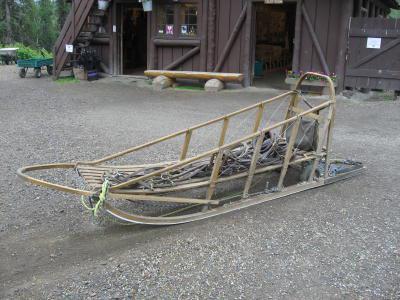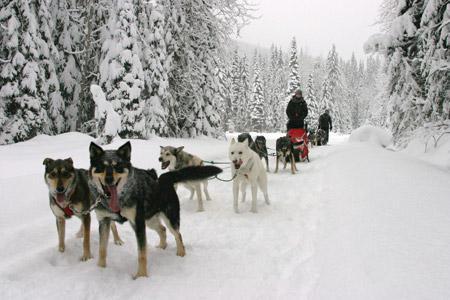The first image is the image on the left, the second image is the image on the right. Assess this claim about the two images: "In at least one image there is a single female with her hair showing and there are eight dogs attached to a sled.". Correct or not? Answer yes or no. No. The first image is the image on the left, the second image is the image on the right. Examine the images to the left and right. Is the description "The sled in the image on the left is unoccupied." accurate? Answer yes or no. Yes. 